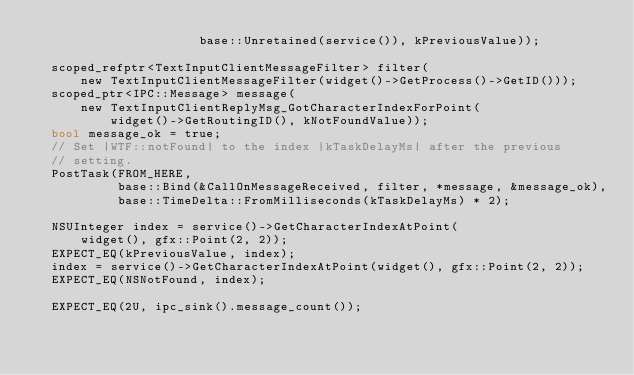<code> <loc_0><loc_0><loc_500><loc_500><_ObjectiveC_>                      base::Unretained(service()), kPreviousValue));

  scoped_refptr<TextInputClientMessageFilter> filter(
      new TextInputClientMessageFilter(widget()->GetProcess()->GetID()));
  scoped_ptr<IPC::Message> message(
      new TextInputClientReplyMsg_GotCharacterIndexForPoint(
          widget()->GetRoutingID(), kNotFoundValue));
  bool message_ok = true;
  // Set |WTF::notFound| to the index |kTaskDelayMs| after the previous
  // setting.
  PostTask(FROM_HERE,
           base::Bind(&CallOnMessageReceived, filter, *message, &message_ok),
           base::TimeDelta::FromMilliseconds(kTaskDelayMs) * 2);

  NSUInteger index = service()->GetCharacterIndexAtPoint(
      widget(), gfx::Point(2, 2));
  EXPECT_EQ(kPreviousValue, index);
  index = service()->GetCharacterIndexAtPoint(widget(), gfx::Point(2, 2));
  EXPECT_EQ(NSNotFound, index);

  EXPECT_EQ(2U, ipc_sink().message_count());</code> 